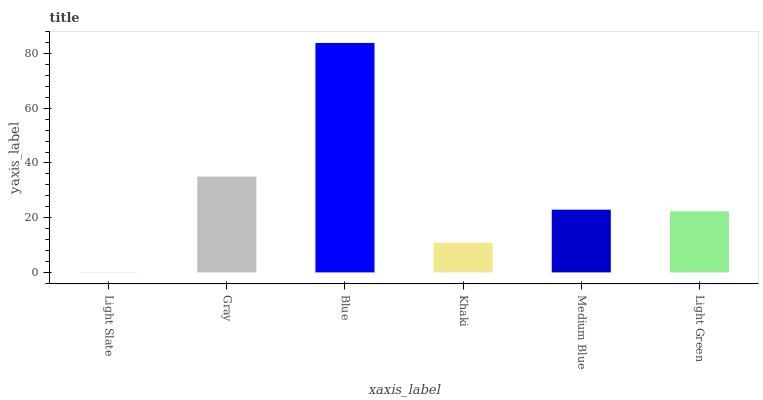Is Light Slate the minimum?
Answer yes or no. Yes. Is Blue the maximum?
Answer yes or no. Yes. Is Gray the minimum?
Answer yes or no. No. Is Gray the maximum?
Answer yes or no. No. Is Gray greater than Light Slate?
Answer yes or no. Yes. Is Light Slate less than Gray?
Answer yes or no. Yes. Is Light Slate greater than Gray?
Answer yes or no. No. Is Gray less than Light Slate?
Answer yes or no. No. Is Medium Blue the high median?
Answer yes or no. Yes. Is Light Green the low median?
Answer yes or no. Yes. Is Light Green the high median?
Answer yes or no. No. Is Khaki the low median?
Answer yes or no. No. 